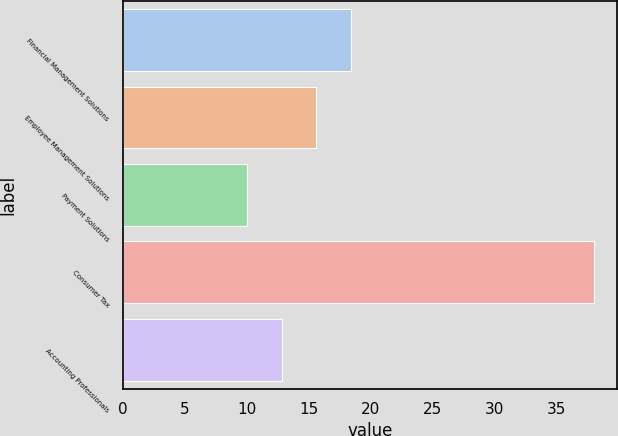Convert chart. <chart><loc_0><loc_0><loc_500><loc_500><bar_chart><fcel>Financial Management Solutions<fcel>Employee Management Solutions<fcel>Payment Solutions<fcel>Consumer Tax<fcel>Accounting Professionals<nl><fcel>18.4<fcel>15.6<fcel>10<fcel>38<fcel>12.8<nl></chart> 